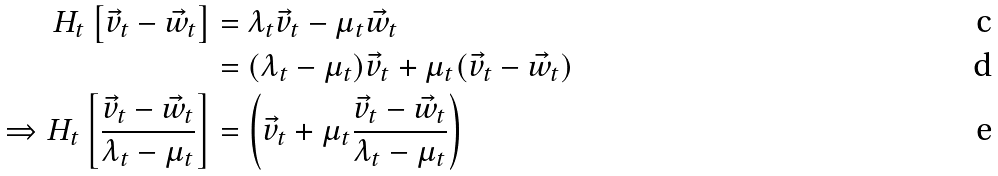<formula> <loc_0><loc_0><loc_500><loc_500>H _ { t } \left [ \vec { v } _ { t } - \vec { w } _ { t } \right ] & = \lambda _ { t } \vec { v } _ { t } - \mu _ { t } \vec { w } _ { t } \\ & = ( \lambda _ { t } - \mu _ { t } ) \vec { v } _ { t } + \mu _ { t } ( \vec { v } _ { t } - \vec { w } _ { t } ) \\ \Rightarrow H _ { t } \left [ \frac { \vec { v } _ { t } - \vec { w } _ { t } } { \lambda _ { t } - \mu _ { t } } \right ] & = \left ( \vec { v } _ { t } + \mu _ { t } \frac { \vec { v } _ { t } - \vec { w } _ { t } } { \lambda _ { t } - \mu _ { t } } \right )</formula> 